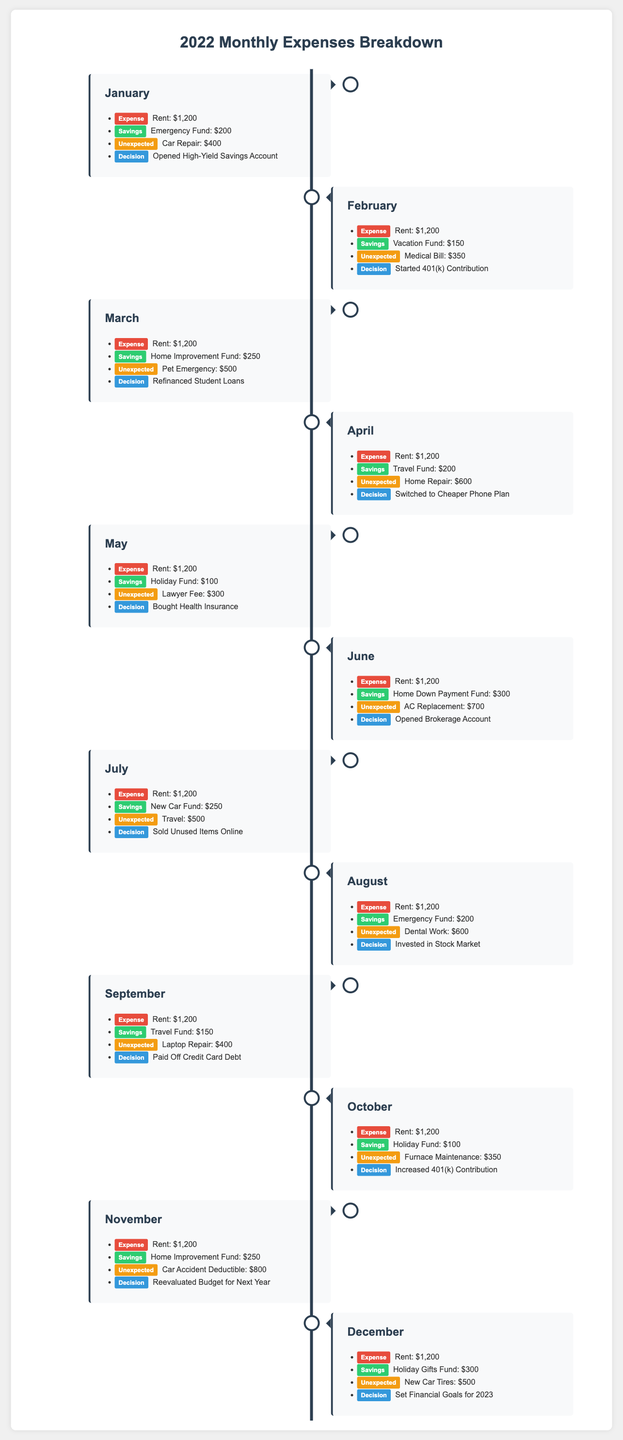what was the rent amount for each month? The rent amount for each month is consistently listed as $1,200 across all months from January to December.
Answer: $1,200 which month had the highest unexpected expense? The month with the highest unexpected expense is November with a car accident deductible of $800.
Answer: $800 how much was contributed to the Emergency Fund in January? The Emergency Fund contribution for January is explicitly noted as $200.
Answer: $200 which decision was made in June? In June, the decision made was to open a brokerage account.
Answer: Opened Brokerage Account how much was saved for the Holiday Gifts Fund in December? The Holiday Gifts Fund saved amount for December is noted as $300.
Answer: $300 what was the total amount spent on unexpected expenses from January to March? The total unexpected expenses from January to March are $400 (car repair) + $350 (medical bill) + $500 (pet emergency), totaling $1,250.
Answer: $1,250 what financial decision was made in September? The financial decision made in September was to pay off credit card debt.
Answer: Paid Off Credit Card Debt how much was saved for the Home Improvement Fund in March? In March, the amount saved for the Home Improvement Fund was $250.
Answer: $250 which month had a decision to reevaluate the budget? The month where there was a decision to reevaluate the budget was November.
Answer: November 